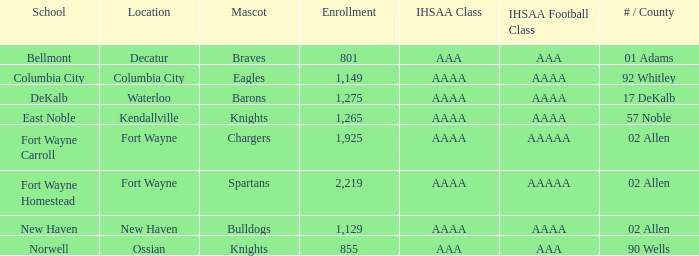What's the registration for kendallville? 1265.0. 